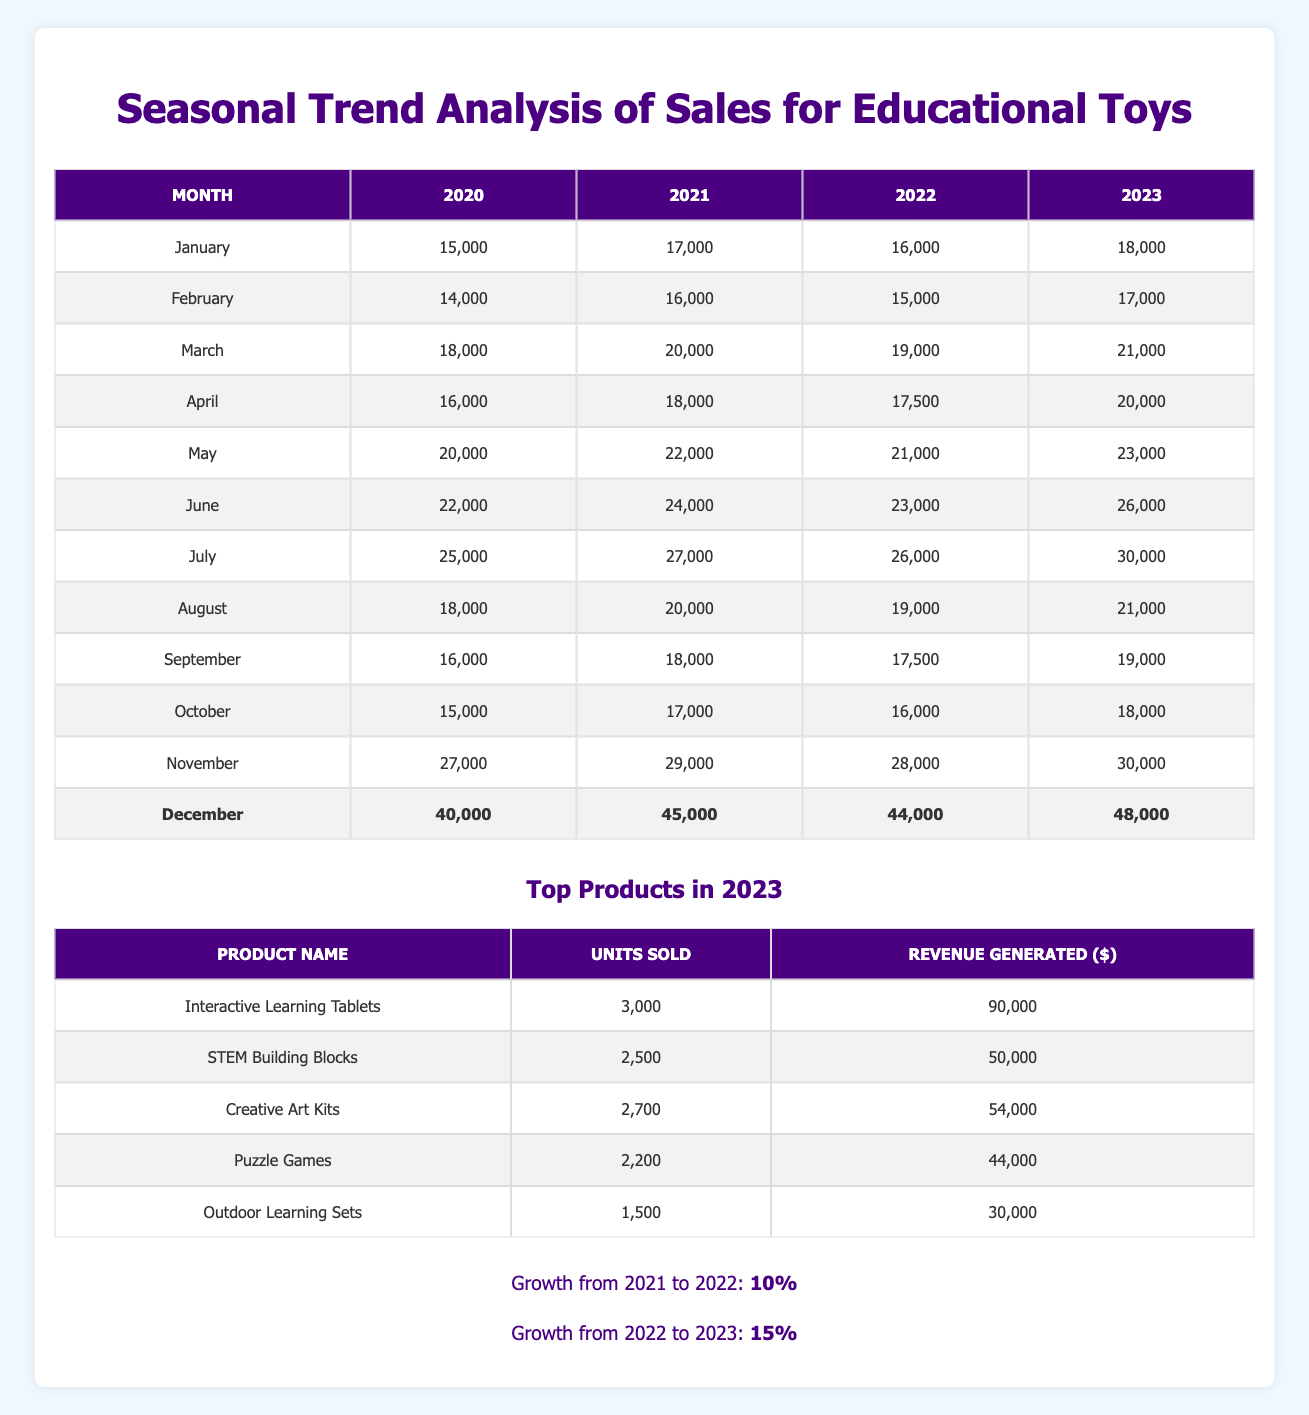What was the sales figure for December 2022? Referring to the table, the sales figure for December 2022 is located in the December row under the 2022 column, which shows 44,000.
Answer: 44,000 What is the total sales for the month of June across all four years? To calculate the total sales for June, sum the values from each year: 22,000 + 24,000 + 23,000 + 26,000 = 95,000.
Answer: 95,000 Did sales in July 2023 exceed those in July 2022? Comparing the values, July 2023 shows 30,000 while July 2022 shows 26,000. Since 30,000 is greater than 26,000, the statement is true.
Answer: Yes What was the average sales for May from 2020 to 2023? The May sales figures for the years 2020 to 2023 are: 20,000, 22,000, 21,000, and 23,000. To find the average, add these values: (20,000 + 22,000 + 21,000 + 23,000) = 86,000, then divide by 4: 86,000 / 4 = 21,500.
Answer: 21,500 Which product sold the most units in 2023 and what is the revenue generated by it? Referring to the top products table for 2023, the product with the highest units sold is "Interactive Learning Tablets" with 3,000 units, generating a revenue of 90,000.
Answer: Interactive Learning Tablets, 90,000 What is the growth percentage from 2021 to 2023? The growth percentage from 2021 to 2022 is 10%, and from 2022 to 2023 is 15%. To find the total growth from 2021 to 2023, we can calculate it stepwise, but since each segment shows an individual growth, this cannot be summed directly. Thus, final growth percentage remains noted as separate segments: 10% and 15%.
Answer: 10% and 15% In which month did sales reach a maximum in December across the years 2020 to 2023? By checking the December sales figures in each year, the values are 40,000 (2020), 45,000 (2021), 44,000 (2022), and 48,000 (2023). The highest figure is 48,000 in December 2023.
Answer: December 2023 What product generates the least revenue in 2023, and what is that revenue? Looking at the top products table for 2023, "Outdoor Learning Sets" generated the least revenue at 30,000.
Answer: Outdoor Learning Sets, 30,000 Is it true that sales in March 2022 are less than sales in March 2023? In March 2022, sales are 19,000 and in March 2023, sales are 21,000. Since 21,000 is greater than 19,000, the statement is true.
Answer: Yes 